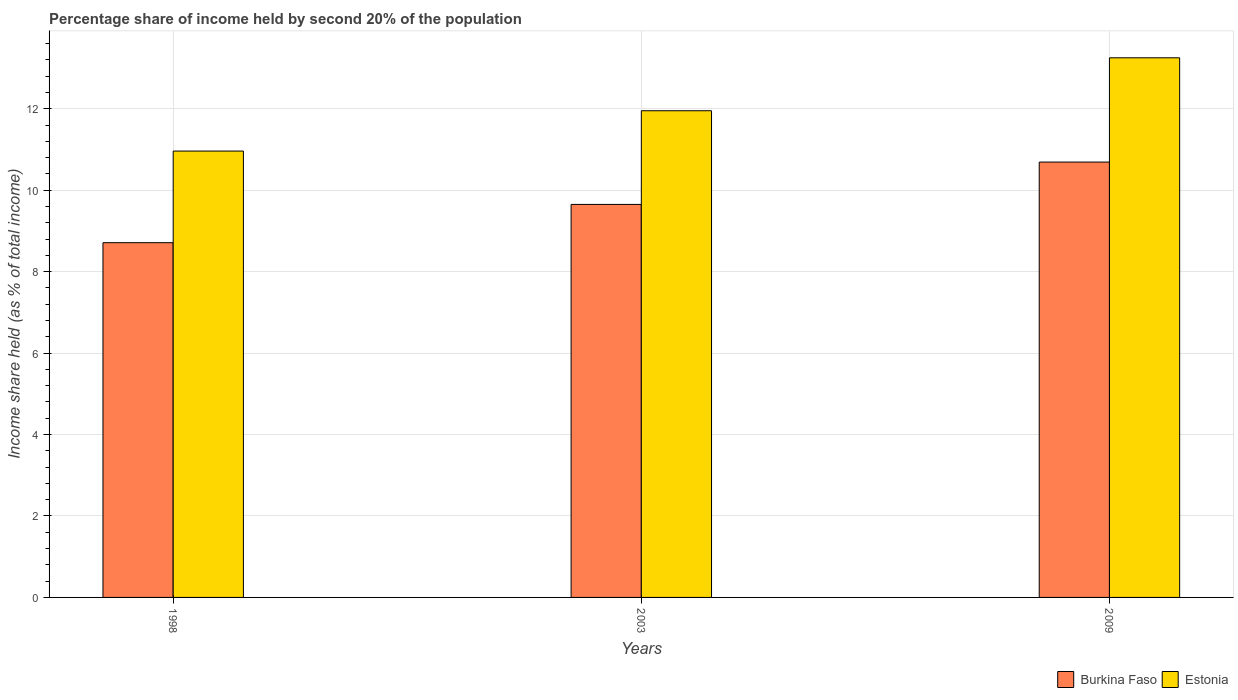How many groups of bars are there?
Your answer should be very brief. 3. Are the number of bars per tick equal to the number of legend labels?
Your answer should be compact. Yes. What is the share of income held by second 20% of the population in Estonia in 2003?
Your answer should be very brief. 11.95. Across all years, what is the maximum share of income held by second 20% of the population in Estonia?
Offer a terse response. 13.25. Across all years, what is the minimum share of income held by second 20% of the population in Estonia?
Your answer should be very brief. 10.96. In which year was the share of income held by second 20% of the population in Estonia maximum?
Provide a succinct answer. 2009. In which year was the share of income held by second 20% of the population in Estonia minimum?
Provide a succinct answer. 1998. What is the total share of income held by second 20% of the population in Burkina Faso in the graph?
Keep it short and to the point. 29.05. What is the difference between the share of income held by second 20% of the population in Burkina Faso in 2003 and that in 2009?
Provide a short and direct response. -1.04. What is the difference between the share of income held by second 20% of the population in Burkina Faso in 2003 and the share of income held by second 20% of the population in Estonia in 2009?
Your answer should be very brief. -3.6. What is the average share of income held by second 20% of the population in Burkina Faso per year?
Provide a short and direct response. 9.68. In the year 2009, what is the difference between the share of income held by second 20% of the population in Estonia and share of income held by second 20% of the population in Burkina Faso?
Provide a succinct answer. 2.56. In how many years, is the share of income held by second 20% of the population in Estonia greater than 3.2 %?
Your response must be concise. 3. What is the ratio of the share of income held by second 20% of the population in Burkina Faso in 1998 to that in 2009?
Give a very brief answer. 0.81. Is the share of income held by second 20% of the population in Burkina Faso in 1998 less than that in 2009?
Ensure brevity in your answer.  Yes. What is the difference between the highest and the second highest share of income held by second 20% of the population in Estonia?
Make the answer very short. 1.3. What is the difference between the highest and the lowest share of income held by second 20% of the population in Estonia?
Provide a short and direct response. 2.29. In how many years, is the share of income held by second 20% of the population in Burkina Faso greater than the average share of income held by second 20% of the population in Burkina Faso taken over all years?
Keep it short and to the point. 1. What does the 2nd bar from the left in 2003 represents?
Offer a very short reply. Estonia. What does the 2nd bar from the right in 2003 represents?
Your response must be concise. Burkina Faso. What is the difference between two consecutive major ticks on the Y-axis?
Provide a short and direct response. 2. Are the values on the major ticks of Y-axis written in scientific E-notation?
Your answer should be compact. No. Does the graph contain any zero values?
Your answer should be compact. No. Where does the legend appear in the graph?
Ensure brevity in your answer.  Bottom right. How are the legend labels stacked?
Your answer should be compact. Horizontal. What is the title of the graph?
Make the answer very short. Percentage share of income held by second 20% of the population. What is the label or title of the Y-axis?
Make the answer very short. Income share held (as % of total income). What is the Income share held (as % of total income) of Burkina Faso in 1998?
Give a very brief answer. 8.71. What is the Income share held (as % of total income) of Estonia in 1998?
Offer a very short reply. 10.96. What is the Income share held (as % of total income) in Burkina Faso in 2003?
Offer a very short reply. 9.65. What is the Income share held (as % of total income) of Estonia in 2003?
Offer a terse response. 11.95. What is the Income share held (as % of total income) in Burkina Faso in 2009?
Give a very brief answer. 10.69. What is the Income share held (as % of total income) of Estonia in 2009?
Offer a very short reply. 13.25. Across all years, what is the maximum Income share held (as % of total income) of Burkina Faso?
Provide a succinct answer. 10.69. Across all years, what is the maximum Income share held (as % of total income) in Estonia?
Your answer should be very brief. 13.25. Across all years, what is the minimum Income share held (as % of total income) in Burkina Faso?
Provide a succinct answer. 8.71. Across all years, what is the minimum Income share held (as % of total income) of Estonia?
Provide a short and direct response. 10.96. What is the total Income share held (as % of total income) in Burkina Faso in the graph?
Your response must be concise. 29.05. What is the total Income share held (as % of total income) in Estonia in the graph?
Provide a short and direct response. 36.16. What is the difference between the Income share held (as % of total income) in Burkina Faso in 1998 and that in 2003?
Make the answer very short. -0.94. What is the difference between the Income share held (as % of total income) in Estonia in 1998 and that in 2003?
Provide a succinct answer. -0.99. What is the difference between the Income share held (as % of total income) in Burkina Faso in 1998 and that in 2009?
Provide a short and direct response. -1.98. What is the difference between the Income share held (as % of total income) of Estonia in 1998 and that in 2009?
Keep it short and to the point. -2.29. What is the difference between the Income share held (as % of total income) of Burkina Faso in 2003 and that in 2009?
Ensure brevity in your answer.  -1.04. What is the difference between the Income share held (as % of total income) in Estonia in 2003 and that in 2009?
Provide a succinct answer. -1.3. What is the difference between the Income share held (as % of total income) in Burkina Faso in 1998 and the Income share held (as % of total income) in Estonia in 2003?
Offer a very short reply. -3.24. What is the difference between the Income share held (as % of total income) of Burkina Faso in 1998 and the Income share held (as % of total income) of Estonia in 2009?
Offer a terse response. -4.54. What is the average Income share held (as % of total income) in Burkina Faso per year?
Provide a short and direct response. 9.68. What is the average Income share held (as % of total income) of Estonia per year?
Offer a terse response. 12.05. In the year 1998, what is the difference between the Income share held (as % of total income) of Burkina Faso and Income share held (as % of total income) of Estonia?
Provide a succinct answer. -2.25. In the year 2009, what is the difference between the Income share held (as % of total income) in Burkina Faso and Income share held (as % of total income) in Estonia?
Your response must be concise. -2.56. What is the ratio of the Income share held (as % of total income) in Burkina Faso in 1998 to that in 2003?
Your response must be concise. 0.9. What is the ratio of the Income share held (as % of total income) in Estonia in 1998 to that in 2003?
Make the answer very short. 0.92. What is the ratio of the Income share held (as % of total income) of Burkina Faso in 1998 to that in 2009?
Your answer should be compact. 0.81. What is the ratio of the Income share held (as % of total income) of Estonia in 1998 to that in 2009?
Offer a very short reply. 0.83. What is the ratio of the Income share held (as % of total income) of Burkina Faso in 2003 to that in 2009?
Give a very brief answer. 0.9. What is the ratio of the Income share held (as % of total income) in Estonia in 2003 to that in 2009?
Offer a terse response. 0.9. What is the difference between the highest and the second highest Income share held (as % of total income) of Estonia?
Provide a succinct answer. 1.3. What is the difference between the highest and the lowest Income share held (as % of total income) of Burkina Faso?
Your answer should be compact. 1.98. What is the difference between the highest and the lowest Income share held (as % of total income) of Estonia?
Keep it short and to the point. 2.29. 